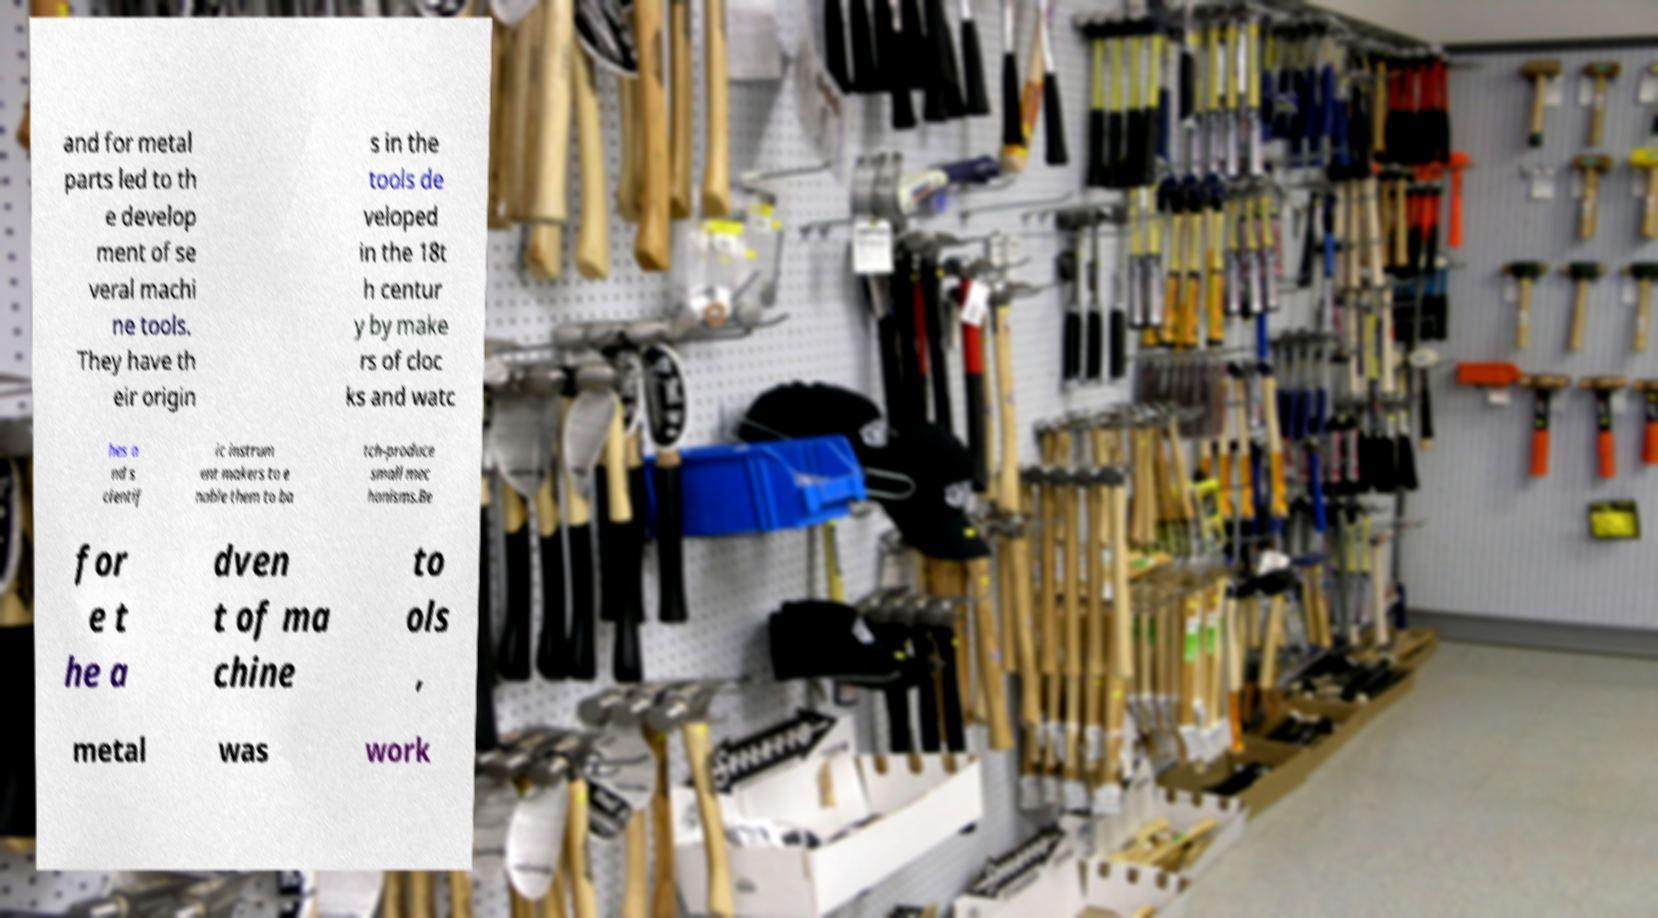Could you assist in decoding the text presented in this image and type it out clearly? and for metal parts led to th e develop ment of se veral machi ne tools. They have th eir origin s in the tools de veloped in the 18t h centur y by make rs of cloc ks and watc hes a nd s cientif ic instrum ent makers to e nable them to ba tch-produce small mec hanisms.Be for e t he a dven t of ma chine to ols , metal was work 